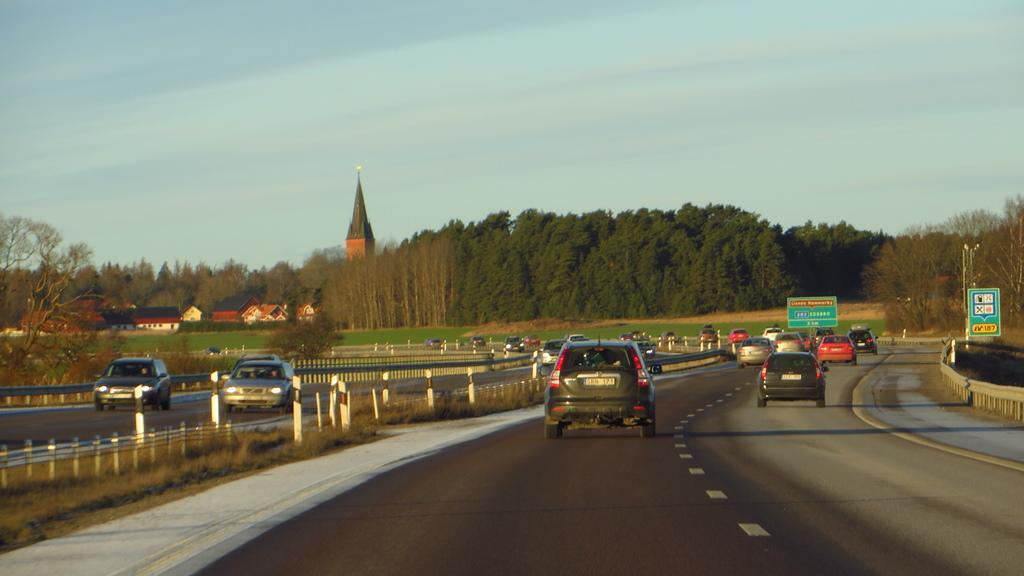Could you give a brief overview of what you see in this image? In this image there is the sky towards the top of the image, there are trees, there are trees, there is a building, there are houses towards the left of the image, there is grass, there is road towards the bottom of the image, there are vehicles on the road, there are boards, there is text on the board, there are poles towards the right of the image. 